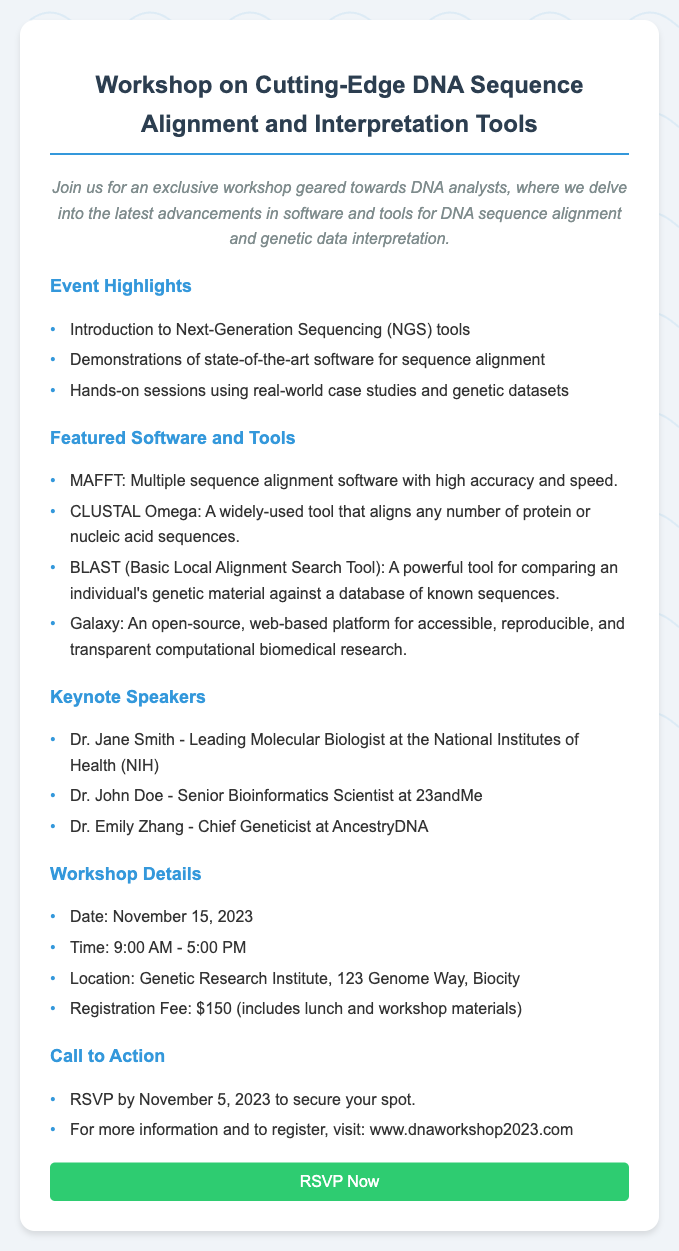What is the workshop date? The date of the workshop is clearly indicated in the document as November 15, 2023.
Answer: November 15, 2023 Who is one of the keynote speakers? The document lists several keynote speakers, for example, Dr. Jane Smith is mentioned as a leading molecular biologist.
Answer: Dr. Jane Smith What is the registration fee for the workshop? The registration fee is specified in the document, which is $150, including lunch and materials.
Answer: $150 What is one of the featured software tools? The document highlights several software tools, one of which is MAFFT.
Answer: MAFFT By what date should you RSVP? The document clearly states that RSVPs must be made by November 5, 2023.
Answer: November 5, 2023 What time does the workshop start? The starting time for the workshop is given as 9:00 AM in the document.
Answer: 9:00 AM What type of session is included in the workshop? The document mentions hands-on sessions, which involve real-world case studies and datasets.
Answer: Hands-on sessions Where is the workshop location? The workshop location is provided in the document as the Genetic Research Institute, 123 Genome Way, Biocity.
Answer: Genetic Research Institute, 123 Genome Way, Biocity 